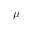<formula> <loc_0><loc_0><loc_500><loc_500>\mu</formula> 